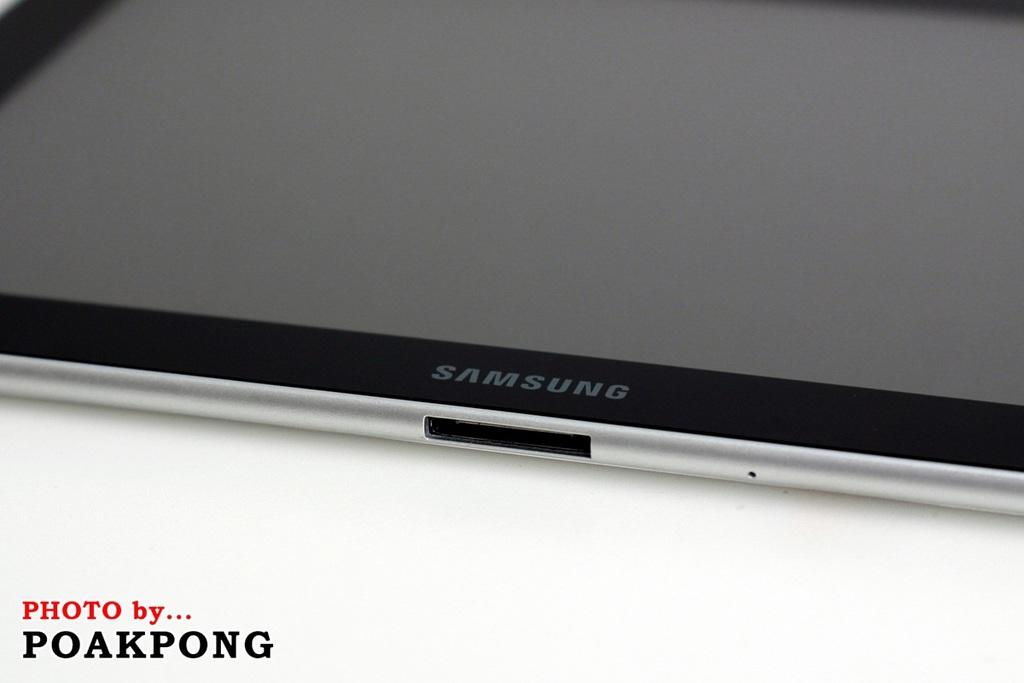What is the brand of phone?
Your answer should be compact. Samsung. 